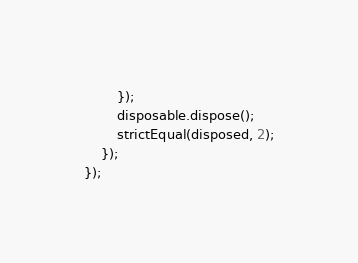<code> <loc_0><loc_0><loc_500><loc_500><_TypeScript_>		});
		disposable.dispose();
		strictEqual(disposed, 2);
	});
});</code> 